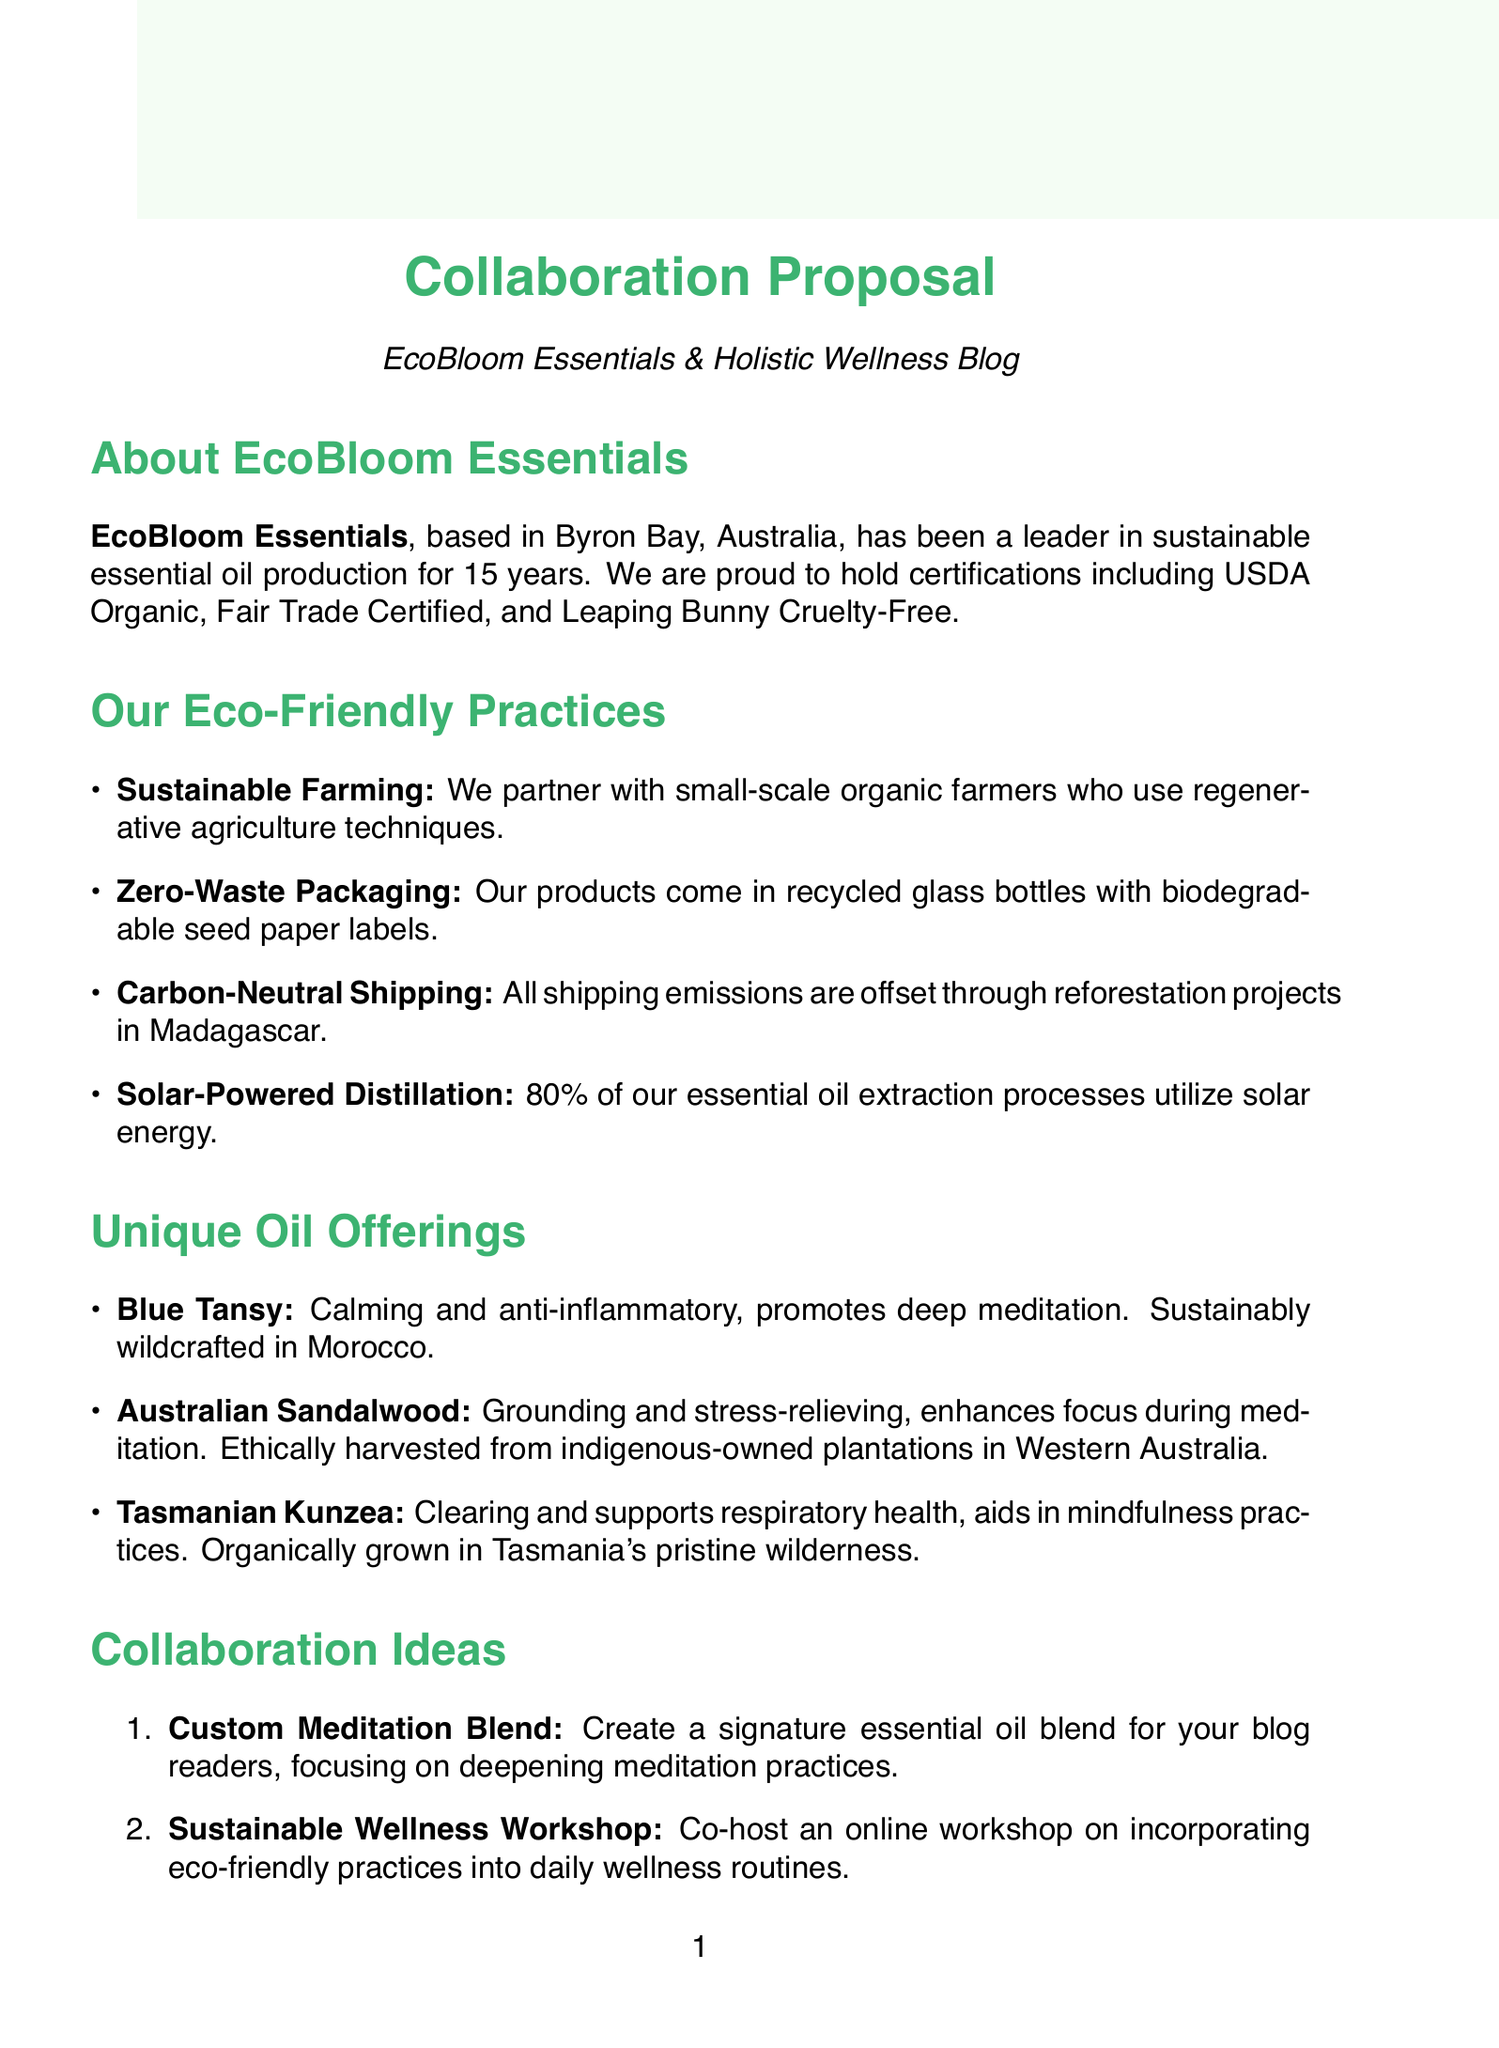What is the company name of the supplier? The company name is mentioned in the introduction of the document.
Answer: EcoBloom Essentials Where is EcoBloom Essentials located? The location is provided at the beginning of the document.
Answer: Byron Bay, Australia How many years has EcoBloom Essentials been in business? The duration of the business operation is specified in the document.
Answer: 15 What certification does EcoBloom Essentials hold? The certifications are listed in the introduction section.
Answer: USDA Organic, Fair Trade Certified, Leaping Bunny Cruelty-Free What unique oil is sustainably wildcrafted in Morocco? This information is found in the unique oil offerings section.
Answer: Blue Tansy What is the main benefit of Australian Sandalwood? The benefits of the unique oils are described in their respective entries.
Answer: Grounding, stress-relief, enhances focus during meditation What is one proposed collaboration idea? Collaboration ideas are listed towards the end of the document.
Answer: Custom Meditation Blend How does EcoBloom Essentials achieve carbon-neutral shipping? This is detailed under eco-friendly practices.
Answer: Offset all shipping emissions through reforestation projects in Madagascar What percentage of oil extraction processes utilize solar energy? This information is provided in the eco-friendly practices section.
Answer: 80% What is the next step mentioned for collaboration? The next steps are clearly outlined at the end of the document.
Answer: Schedule a video call to discuss collaboration details 